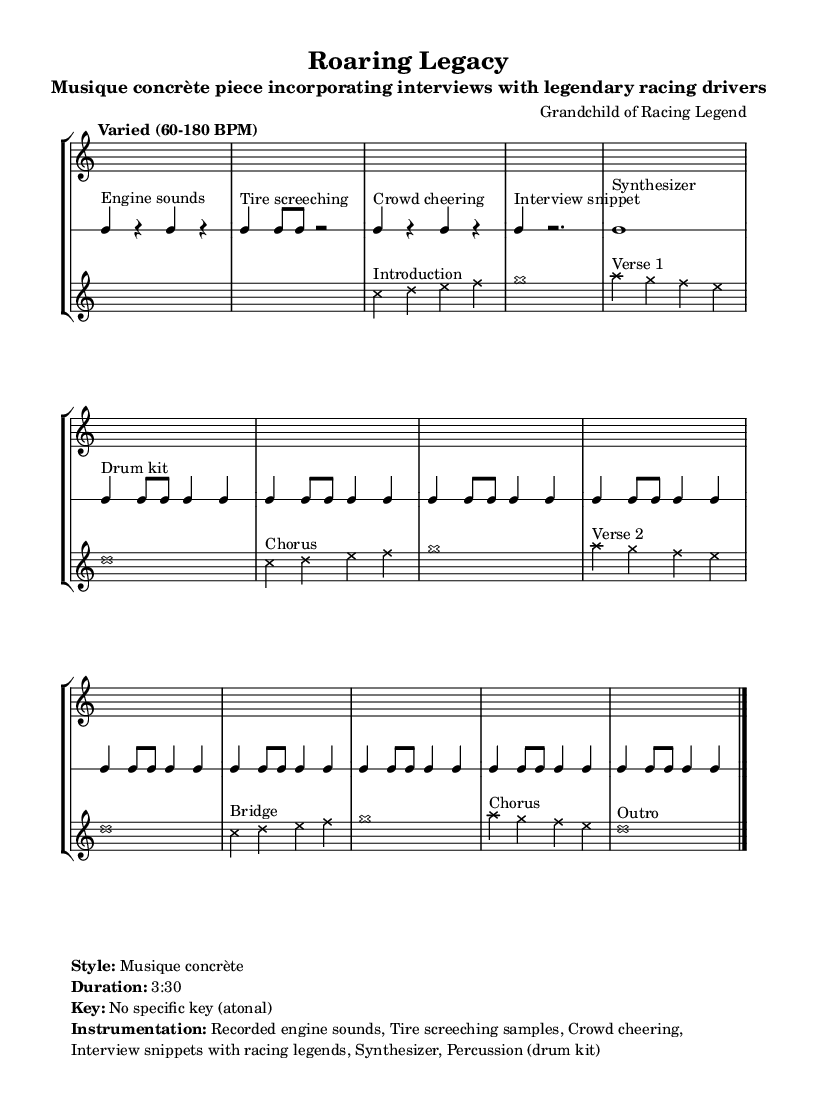What is the title of this piece? The title is located in the header section of the code, which is set to "Roaring Legacy."
Answer: Roaring Legacy What is the duration of the piece? The duration is indicated in the markup section of the code as "3:30."
Answer: 3:30 What is the time signature of the music? The time signature can be found in the staff definition; it is set to 4/4 in both rhythmic and musical parts.
Answer: 4/4 Which instruments are included in this piece? The instrumentation is listed in the markup section and includes recorded engine sounds, tire screeching samples, crowd cheering, interview snippets with racing legends, a synthesizer, and a drum kit.
Answer: Recorded engine sounds, Tire screeching samples, Crowd cheering, Interview snippets with racing legends, Synthesizer, Percussion (drum kit) How does the piece incorporate elements of musique concrète? The piece employs real-world recorded sounds (engine noises, tire screeching, crowd cheering) alongside musical elements, which is a hallmark of musique concrète. This mixture reflects the genre's focus on blending environmental sounds with musical commentary.
Answer: Real-world recorded sounds What is the tempo range specified for this piece? The tempo range is indicated in the tempo directive, which states "Varied (60-180 BPM)," indicating the piece can vary significantly in speed.
Answer: 60-180 BPM What type of musical structure does this piece use? The structure includes distinct sections such as verses, a chorus, and a bridge, which is typical in contemporary experimental compositions that fuse traditional elements with unique soundscapes.
Answer: Introduction, Verse 1, Chorus, Verse 2, Bridge, Outro 